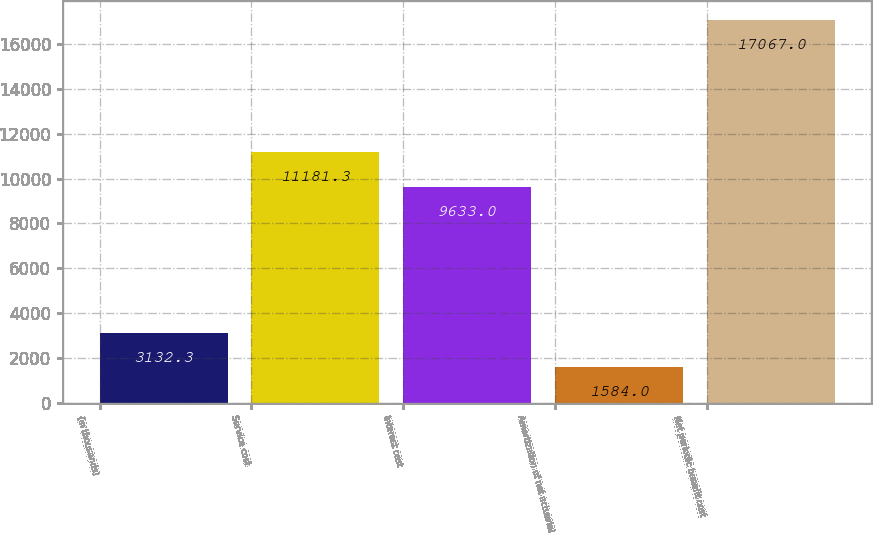Convert chart to OTSL. <chart><loc_0><loc_0><loc_500><loc_500><bar_chart><fcel>(in thousands)<fcel>Service cost<fcel>Interest cost<fcel>Amortization of net actuarial<fcel>Net periodic benefit cost<nl><fcel>3132.3<fcel>11181.3<fcel>9633<fcel>1584<fcel>17067<nl></chart> 